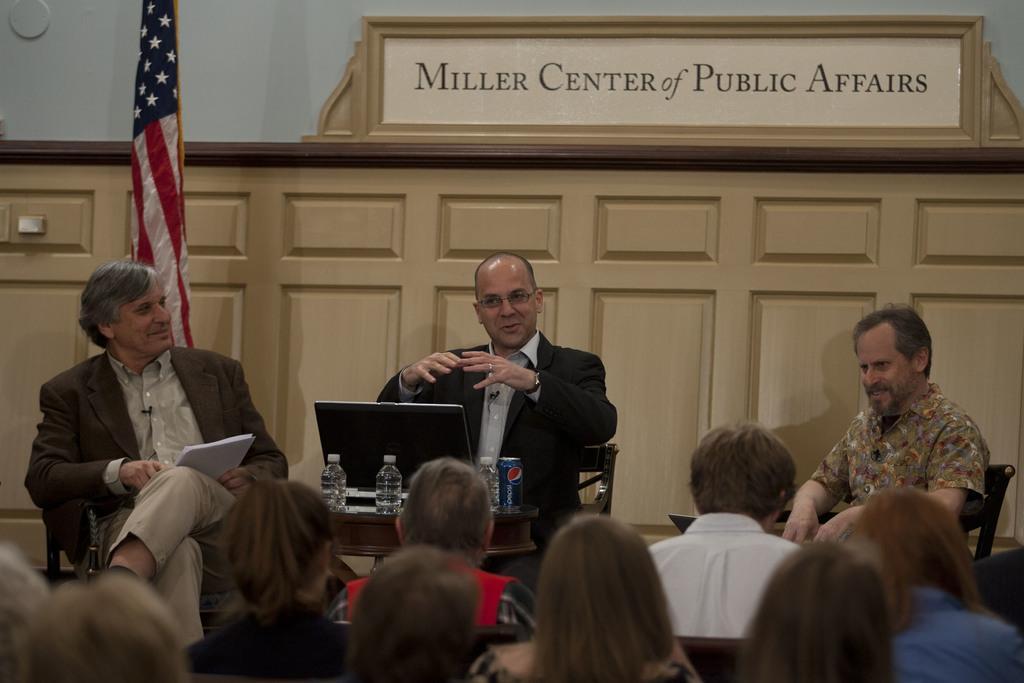Please provide a concise description of this image. In the image in the center we can see three persons were sitting on the chair and they were smiling,which we can see on their faces. In front of them,there is a table. On table,we can see can,water bottles and laptop. In the bottom of the image we can see few people were sitting. In the background there is a wall,wood and flag. 